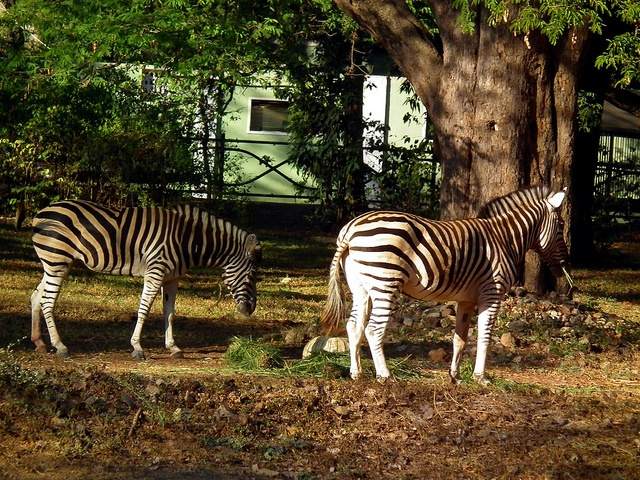Describe the objects in this image and their specific colors. I can see zebra in tan, black, white, and maroon tones and zebra in tan, black, and olive tones in this image. 